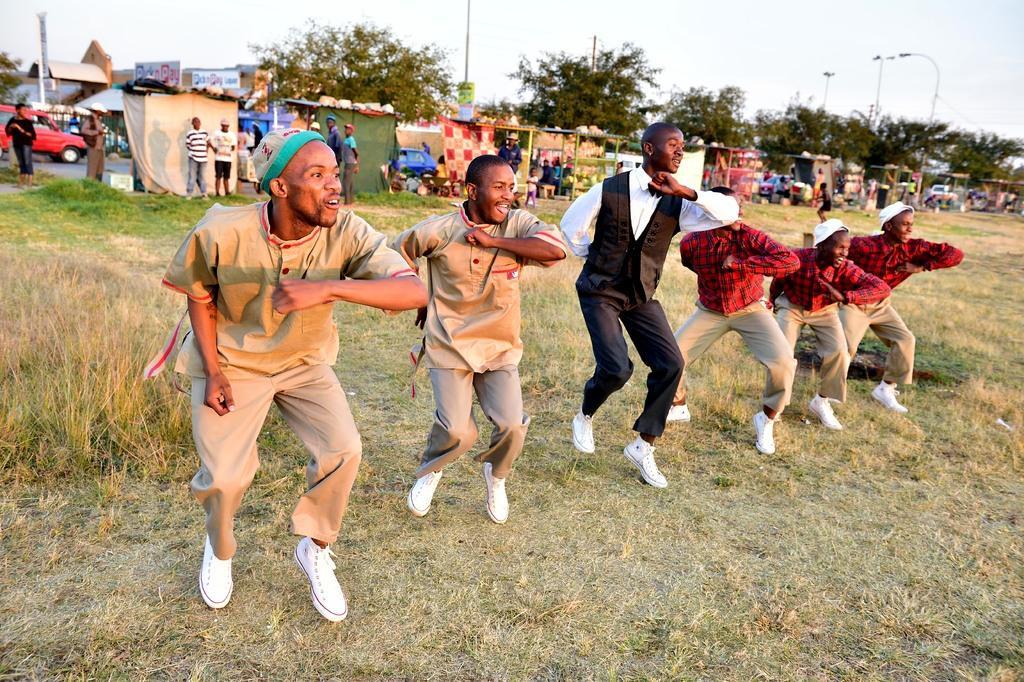Can you describe this image briefly? This image is clicked outside. There are stores in the middle. There are trees at the top. There are lights at the top. There is a car on the left side. There are some persons in the middle, dancing. There is grass at the bottom. 